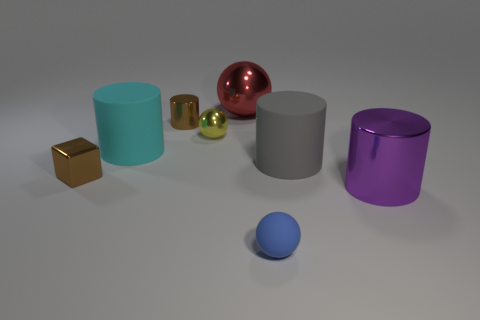The other shiny object that is the same shape as the large purple object is what color?
Give a very brief answer. Brown. Does the large gray matte thing have the same shape as the large red thing?
Your answer should be very brief. No. How many spheres are cyan objects or gray matte things?
Provide a short and direct response. 0. There is a small ball that is the same material as the large cyan object; what color is it?
Your answer should be compact. Blue. Is the size of the thing that is on the right side of the gray rubber object the same as the big gray object?
Your response must be concise. Yes. Is the purple object made of the same material as the small ball behind the blue matte thing?
Provide a short and direct response. Yes. What color is the tiny sphere that is behind the tiny blue rubber sphere?
Your answer should be very brief. Yellow. There is a metal cylinder left of the big gray object; is there a blue rubber object behind it?
Offer a very short reply. No. Do the small metal object in front of the big cyan rubber thing and the large object left of the tiny brown cylinder have the same color?
Offer a terse response. No. There is a big red ball; how many large gray matte cylinders are in front of it?
Offer a very short reply. 1. 